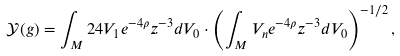Convert formula to latex. <formula><loc_0><loc_0><loc_500><loc_500>\mathcal { Y } ( g ) = \int _ { M } 2 4 V _ { 1 } e ^ { - 4 \rho } z ^ { - 3 } d V _ { 0 } \cdot \left ( \int _ { M } V _ { n } e ^ { - 4 \rho } z ^ { - 3 } d V _ { 0 } \right ) ^ { - 1 / 2 } ,</formula> 